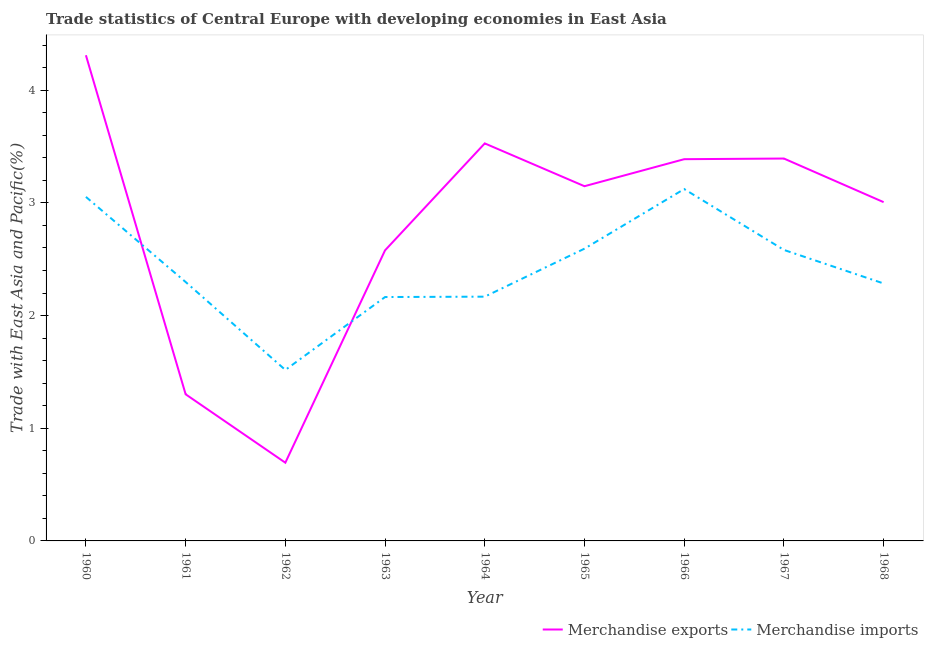How many different coloured lines are there?
Give a very brief answer. 2. Does the line corresponding to merchandise exports intersect with the line corresponding to merchandise imports?
Offer a very short reply. Yes. Is the number of lines equal to the number of legend labels?
Provide a short and direct response. Yes. What is the merchandise imports in 1966?
Offer a very short reply. 3.12. Across all years, what is the maximum merchandise imports?
Your response must be concise. 3.12. Across all years, what is the minimum merchandise exports?
Keep it short and to the point. 0.69. In which year was the merchandise imports minimum?
Offer a very short reply. 1962. What is the total merchandise imports in the graph?
Your response must be concise. 21.79. What is the difference between the merchandise imports in 1962 and that in 1963?
Your response must be concise. -0.65. What is the difference between the merchandise imports in 1964 and the merchandise exports in 1960?
Give a very brief answer. -2.14. What is the average merchandise exports per year?
Ensure brevity in your answer.  2.82. In the year 1962, what is the difference between the merchandise exports and merchandise imports?
Ensure brevity in your answer.  -0.82. In how many years, is the merchandise exports greater than 1.6 %?
Make the answer very short. 7. What is the ratio of the merchandise exports in 1962 to that in 1968?
Your answer should be compact. 0.23. What is the difference between the highest and the second highest merchandise exports?
Keep it short and to the point. 0.78. What is the difference between the highest and the lowest merchandise exports?
Your response must be concise. 3.62. In how many years, is the merchandise imports greater than the average merchandise imports taken over all years?
Provide a succinct answer. 4. Is the sum of the merchandise exports in 1964 and 1968 greater than the maximum merchandise imports across all years?
Make the answer very short. Yes. Is the merchandise imports strictly less than the merchandise exports over the years?
Offer a terse response. No. How many lines are there?
Offer a terse response. 2. Where does the legend appear in the graph?
Provide a short and direct response. Bottom right. How are the legend labels stacked?
Your response must be concise. Horizontal. What is the title of the graph?
Ensure brevity in your answer.  Trade statistics of Central Europe with developing economies in East Asia. What is the label or title of the X-axis?
Provide a short and direct response. Year. What is the label or title of the Y-axis?
Keep it short and to the point. Trade with East Asia and Pacific(%). What is the Trade with East Asia and Pacific(%) of Merchandise exports in 1960?
Offer a terse response. 4.31. What is the Trade with East Asia and Pacific(%) of Merchandise imports in 1960?
Offer a very short reply. 3.05. What is the Trade with East Asia and Pacific(%) of Merchandise exports in 1961?
Your answer should be very brief. 1.3. What is the Trade with East Asia and Pacific(%) of Merchandise imports in 1961?
Provide a short and direct response. 2.3. What is the Trade with East Asia and Pacific(%) in Merchandise exports in 1962?
Your answer should be very brief. 0.69. What is the Trade with East Asia and Pacific(%) of Merchandise imports in 1962?
Give a very brief answer. 1.52. What is the Trade with East Asia and Pacific(%) in Merchandise exports in 1963?
Offer a terse response. 2.58. What is the Trade with East Asia and Pacific(%) in Merchandise imports in 1963?
Provide a succinct answer. 2.16. What is the Trade with East Asia and Pacific(%) in Merchandise exports in 1964?
Provide a succinct answer. 3.53. What is the Trade with East Asia and Pacific(%) in Merchandise imports in 1964?
Your response must be concise. 2.17. What is the Trade with East Asia and Pacific(%) of Merchandise exports in 1965?
Your response must be concise. 3.15. What is the Trade with East Asia and Pacific(%) of Merchandise imports in 1965?
Give a very brief answer. 2.59. What is the Trade with East Asia and Pacific(%) in Merchandise exports in 1966?
Provide a succinct answer. 3.39. What is the Trade with East Asia and Pacific(%) in Merchandise imports in 1966?
Offer a very short reply. 3.12. What is the Trade with East Asia and Pacific(%) in Merchandise exports in 1967?
Give a very brief answer. 3.39. What is the Trade with East Asia and Pacific(%) in Merchandise imports in 1967?
Ensure brevity in your answer.  2.58. What is the Trade with East Asia and Pacific(%) of Merchandise exports in 1968?
Provide a short and direct response. 3.01. What is the Trade with East Asia and Pacific(%) in Merchandise imports in 1968?
Offer a very short reply. 2.28. Across all years, what is the maximum Trade with East Asia and Pacific(%) of Merchandise exports?
Make the answer very short. 4.31. Across all years, what is the maximum Trade with East Asia and Pacific(%) of Merchandise imports?
Provide a succinct answer. 3.12. Across all years, what is the minimum Trade with East Asia and Pacific(%) of Merchandise exports?
Your answer should be very brief. 0.69. Across all years, what is the minimum Trade with East Asia and Pacific(%) in Merchandise imports?
Ensure brevity in your answer.  1.52. What is the total Trade with East Asia and Pacific(%) in Merchandise exports in the graph?
Your answer should be compact. 25.35. What is the total Trade with East Asia and Pacific(%) of Merchandise imports in the graph?
Your response must be concise. 21.79. What is the difference between the Trade with East Asia and Pacific(%) in Merchandise exports in 1960 and that in 1961?
Provide a short and direct response. 3.01. What is the difference between the Trade with East Asia and Pacific(%) in Merchandise imports in 1960 and that in 1961?
Make the answer very short. 0.76. What is the difference between the Trade with East Asia and Pacific(%) of Merchandise exports in 1960 and that in 1962?
Ensure brevity in your answer.  3.62. What is the difference between the Trade with East Asia and Pacific(%) in Merchandise imports in 1960 and that in 1962?
Offer a terse response. 1.54. What is the difference between the Trade with East Asia and Pacific(%) of Merchandise exports in 1960 and that in 1963?
Give a very brief answer. 1.73. What is the difference between the Trade with East Asia and Pacific(%) in Merchandise imports in 1960 and that in 1963?
Keep it short and to the point. 0.89. What is the difference between the Trade with East Asia and Pacific(%) in Merchandise exports in 1960 and that in 1964?
Keep it short and to the point. 0.78. What is the difference between the Trade with East Asia and Pacific(%) in Merchandise imports in 1960 and that in 1964?
Provide a short and direct response. 0.89. What is the difference between the Trade with East Asia and Pacific(%) in Merchandise exports in 1960 and that in 1965?
Offer a terse response. 1.16. What is the difference between the Trade with East Asia and Pacific(%) in Merchandise imports in 1960 and that in 1965?
Your answer should be compact. 0.46. What is the difference between the Trade with East Asia and Pacific(%) of Merchandise exports in 1960 and that in 1966?
Provide a succinct answer. 0.92. What is the difference between the Trade with East Asia and Pacific(%) of Merchandise imports in 1960 and that in 1966?
Your answer should be very brief. -0.07. What is the difference between the Trade with East Asia and Pacific(%) in Merchandise imports in 1960 and that in 1967?
Offer a very short reply. 0.47. What is the difference between the Trade with East Asia and Pacific(%) of Merchandise exports in 1960 and that in 1968?
Give a very brief answer. 1.3. What is the difference between the Trade with East Asia and Pacific(%) of Merchandise imports in 1960 and that in 1968?
Make the answer very short. 0.77. What is the difference between the Trade with East Asia and Pacific(%) of Merchandise exports in 1961 and that in 1962?
Offer a very short reply. 0.61. What is the difference between the Trade with East Asia and Pacific(%) in Merchandise imports in 1961 and that in 1962?
Your response must be concise. 0.78. What is the difference between the Trade with East Asia and Pacific(%) in Merchandise exports in 1961 and that in 1963?
Provide a short and direct response. -1.28. What is the difference between the Trade with East Asia and Pacific(%) in Merchandise imports in 1961 and that in 1963?
Offer a very short reply. 0.13. What is the difference between the Trade with East Asia and Pacific(%) in Merchandise exports in 1961 and that in 1964?
Your answer should be very brief. -2.23. What is the difference between the Trade with East Asia and Pacific(%) of Merchandise imports in 1961 and that in 1964?
Provide a succinct answer. 0.13. What is the difference between the Trade with East Asia and Pacific(%) of Merchandise exports in 1961 and that in 1965?
Keep it short and to the point. -1.85. What is the difference between the Trade with East Asia and Pacific(%) of Merchandise imports in 1961 and that in 1965?
Make the answer very short. -0.3. What is the difference between the Trade with East Asia and Pacific(%) of Merchandise exports in 1961 and that in 1966?
Your answer should be compact. -2.09. What is the difference between the Trade with East Asia and Pacific(%) in Merchandise imports in 1961 and that in 1966?
Make the answer very short. -0.82. What is the difference between the Trade with East Asia and Pacific(%) in Merchandise exports in 1961 and that in 1967?
Provide a short and direct response. -2.09. What is the difference between the Trade with East Asia and Pacific(%) in Merchandise imports in 1961 and that in 1967?
Make the answer very short. -0.28. What is the difference between the Trade with East Asia and Pacific(%) of Merchandise exports in 1961 and that in 1968?
Give a very brief answer. -1.71. What is the difference between the Trade with East Asia and Pacific(%) in Merchandise imports in 1961 and that in 1968?
Make the answer very short. 0.01. What is the difference between the Trade with East Asia and Pacific(%) in Merchandise exports in 1962 and that in 1963?
Your answer should be compact. -1.88. What is the difference between the Trade with East Asia and Pacific(%) in Merchandise imports in 1962 and that in 1963?
Keep it short and to the point. -0.65. What is the difference between the Trade with East Asia and Pacific(%) of Merchandise exports in 1962 and that in 1964?
Give a very brief answer. -2.83. What is the difference between the Trade with East Asia and Pacific(%) in Merchandise imports in 1962 and that in 1964?
Your answer should be very brief. -0.65. What is the difference between the Trade with East Asia and Pacific(%) of Merchandise exports in 1962 and that in 1965?
Your answer should be compact. -2.45. What is the difference between the Trade with East Asia and Pacific(%) in Merchandise imports in 1962 and that in 1965?
Your answer should be very brief. -1.08. What is the difference between the Trade with East Asia and Pacific(%) of Merchandise exports in 1962 and that in 1966?
Your answer should be compact. -2.69. What is the difference between the Trade with East Asia and Pacific(%) in Merchandise imports in 1962 and that in 1966?
Keep it short and to the point. -1.61. What is the difference between the Trade with East Asia and Pacific(%) in Merchandise exports in 1962 and that in 1967?
Offer a very short reply. -2.7. What is the difference between the Trade with East Asia and Pacific(%) in Merchandise imports in 1962 and that in 1967?
Provide a succinct answer. -1.07. What is the difference between the Trade with East Asia and Pacific(%) of Merchandise exports in 1962 and that in 1968?
Your response must be concise. -2.31. What is the difference between the Trade with East Asia and Pacific(%) in Merchandise imports in 1962 and that in 1968?
Your answer should be compact. -0.77. What is the difference between the Trade with East Asia and Pacific(%) in Merchandise exports in 1963 and that in 1964?
Your answer should be compact. -0.95. What is the difference between the Trade with East Asia and Pacific(%) in Merchandise imports in 1963 and that in 1964?
Offer a terse response. -0. What is the difference between the Trade with East Asia and Pacific(%) of Merchandise exports in 1963 and that in 1965?
Keep it short and to the point. -0.57. What is the difference between the Trade with East Asia and Pacific(%) of Merchandise imports in 1963 and that in 1965?
Your answer should be compact. -0.43. What is the difference between the Trade with East Asia and Pacific(%) of Merchandise exports in 1963 and that in 1966?
Ensure brevity in your answer.  -0.81. What is the difference between the Trade with East Asia and Pacific(%) in Merchandise imports in 1963 and that in 1966?
Your answer should be very brief. -0.96. What is the difference between the Trade with East Asia and Pacific(%) in Merchandise exports in 1963 and that in 1967?
Your response must be concise. -0.81. What is the difference between the Trade with East Asia and Pacific(%) in Merchandise imports in 1963 and that in 1967?
Give a very brief answer. -0.42. What is the difference between the Trade with East Asia and Pacific(%) in Merchandise exports in 1963 and that in 1968?
Ensure brevity in your answer.  -0.43. What is the difference between the Trade with East Asia and Pacific(%) in Merchandise imports in 1963 and that in 1968?
Your response must be concise. -0.12. What is the difference between the Trade with East Asia and Pacific(%) in Merchandise exports in 1964 and that in 1965?
Keep it short and to the point. 0.38. What is the difference between the Trade with East Asia and Pacific(%) of Merchandise imports in 1964 and that in 1965?
Your response must be concise. -0.43. What is the difference between the Trade with East Asia and Pacific(%) of Merchandise exports in 1964 and that in 1966?
Your answer should be very brief. 0.14. What is the difference between the Trade with East Asia and Pacific(%) of Merchandise imports in 1964 and that in 1966?
Your answer should be very brief. -0.96. What is the difference between the Trade with East Asia and Pacific(%) of Merchandise exports in 1964 and that in 1967?
Provide a succinct answer. 0.13. What is the difference between the Trade with East Asia and Pacific(%) of Merchandise imports in 1964 and that in 1967?
Provide a succinct answer. -0.41. What is the difference between the Trade with East Asia and Pacific(%) of Merchandise exports in 1964 and that in 1968?
Provide a short and direct response. 0.52. What is the difference between the Trade with East Asia and Pacific(%) in Merchandise imports in 1964 and that in 1968?
Your response must be concise. -0.12. What is the difference between the Trade with East Asia and Pacific(%) in Merchandise exports in 1965 and that in 1966?
Offer a very short reply. -0.24. What is the difference between the Trade with East Asia and Pacific(%) in Merchandise imports in 1965 and that in 1966?
Offer a very short reply. -0.53. What is the difference between the Trade with East Asia and Pacific(%) of Merchandise exports in 1965 and that in 1967?
Your answer should be compact. -0.25. What is the difference between the Trade with East Asia and Pacific(%) of Merchandise imports in 1965 and that in 1967?
Offer a terse response. 0.01. What is the difference between the Trade with East Asia and Pacific(%) in Merchandise exports in 1965 and that in 1968?
Offer a terse response. 0.14. What is the difference between the Trade with East Asia and Pacific(%) in Merchandise imports in 1965 and that in 1968?
Give a very brief answer. 0.31. What is the difference between the Trade with East Asia and Pacific(%) in Merchandise exports in 1966 and that in 1967?
Your response must be concise. -0.01. What is the difference between the Trade with East Asia and Pacific(%) in Merchandise imports in 1966 and that in 1967?
Keep it short and to the point. 0.54. What is the difference between the Trade with East Asia and Pacific(%) in Merchandise exports in 1966 and that in 1968?
Keep it short and to the point. 0.38. What is the difference between the Trade with East Asia and Pacific(%) in Merchandise imports in 1966 and that in 1968?
Give a very brief answer. 0.84. What is the difference between the Trade with East Asia and Pacific(%) in Merchandise exports in 1967 and that in 1968?
Provide a succinct answer. 0.39. What is the difference between the Trade with East Asia and Pacific(%) in Merchandise imports in 1967 and that in 1968?
Offer a very short reply. 0.3. What is the difference between the Trade with East Asia and Pacific(%) in Merchandise exports in 1960 and the Trade with East Asia and Pacific(%) in Merchandise imports in 1961?
Your answer should be very brief. 2.01. What is the difference between the Trade with East Asia and Pacific(%) of Merchandise exports in 1960 and the Trade with East Asia and Pacific(%) of Merchandise imports in 1962?
Provide a succinct answer. 2.79. What is the difference between the Trade with East Asia and Pacific(%) in Merchandise exports in 1960 and the Trade with East Asia and Pacific(%) in Merchandise imports in 1963?
Offer a terse response. 2.15. What is the difference between the Trade with East Asia and Pacific(%) in Merchandise exports in 1960 and the Trade with East Asia and Pacific(%) in Merchandise imports in 1964?
Offer a terse response. 2.14. What is the difference between the Trade with East Asia and Pacific(%) of Merchandise exports in 1960 and the Trade with East Asia and Pacific(%) of Merchandise imports in 1965?
Offer a very short reply. 1.72. What is the difference between the Trade with East Asia and Pacific(%) of Merchandise exports in 1960 and the Trade with East Asia and Pacific(%) of Merchandise imports in 1966?
Offer a terse response. 1.19. What is the difference between the Trade with East Asia and Pacific(%) of Merchandise exports in 1960 and the Trade with East Asia and Pacific(%) of Merchandise imports in 1967?
Your answer should be compact. 1.73. What is the difference between the Trade with East Asia and Pacific(%) of Merchandise exports in 1960 and the Trade with East Asia and Pacific(%) of Merchandise imports in 1968?
Ensure brevity in your answer.  2.03. What is the difference between the Trade with East Asia and Pacific(%) in Merchandise exports in 1961 and the Trade with East Asia and Pacific(%) in Merchandise imports in 1962?
Ensure brevity in your answer.  -0.22. What is the difference between the Trade with East Asia and Pacific(%) of Merchandise exports in 1961 and the Trade with East Asia and Pacific(%) of Merchandise imports in 1963?
Your answer should be very brief. -0.86. What is the difference between the Trade with East Asia and Pacific(%) of Merchandise exports in 1961 and the Trade with East Asia and Pacific(%) of Merchandise imports in 1964?
Make the answer very short. -0.87. What is the difference between the Trade with East Asia and Pacific(%) in Merchandise exports in 1961 and the Trade with East Asia and Pacific(%) in Merchandise imports in 1965?
Make the answer very short. -1.29. What is the difference between the Trade with East Asia and Pacific(%) of Merchandise exports in 1961 and the Trade with East Asia and Pacific(%) of Merchandise imports in 1966?
Offer a terse response. -1.82. What is the difference between the Trade with East Asia and Pacific(%) in Merchandise exports in 1961 and the Trade with East Asia and Pacific(%) in Merchandise imports in 1967?
Make the answer very short. -1.28. What is the difference between the Trade with East Asia and Pacific(%) of Merchandise exports in 1961 and the Trade with East Asia and Pacific(%) of Merchandise imports in 1968?
Offer a very short reply. -0.98. What is the difference between the Trade with East Asia and Pacific(%) in Merchandise exports in 1962 and the Trade with East Asia and Pacific(%) in Merchandise imports in 1963?
Ensure brevity in your answer.  -1.47. What is the difference between the Trade with East Asia and Pacific(%) in Merchandise exports in 1962 and the Trade with East Asia and Pacific(%) in Merchandise imports in 1964?
Provide a short and direct response. -1.47. What is the difference between the Trade with East Asia and Pacific(%) in Merchandise exports in 1962 and the Trade with East Asia and Pacific(%) in Merchandise imports in 1965?
Provide a short and direct response. -1.9. What is the difference between the Trade with East Asia and Pacific(%) in Merchandise exports in 1962 and the Trade with East Asia and Pacific(%) in Merchandise imports in 1966?
Provide a succinct answer. -2.43. What is the difference between the Trade with East Asia and Pacific(%) in Merchandise exports in 1962 and the Trade with East Asia and Pacific(%) in Merchandise imports in 1967?
Provide a short and direct response. -1.89. What is the difference between the Trade with East Asia and Pacific(%) of Merchandise exports in 1962 and the Trade with East Asia and Pacific(%) of Merchandise imports in 1968?
Ensure brevity in your answer.  -1.59. What is the difference between the Trade with East Asia and Pacific(%) of Merchandise exports in 1963 and the Trade with East Asia and Pacific(%) of Merchandise imports in 1964?
Provide a succinct answer. 0.41. What is the difference between the Trade with East Asia and Pacific(%) in Merchandise exports in 1963 and the Trade with East Asia and Pacific(%) in Merchandise imports in 1965?
Your answer should be compact. -0.01. What is the difference between the Trade with East Asia and Pacific(%) in Merchandise exports in 1963 and the Trade with East Asia and Pacific(%) in Merchandise imports in 1966?
Your response must be concise. -0.54. What is the difference between the Trade with East Asia and Pacific(%) in Merchandise exports in 1963 and the Trade with East Asia and Pacific(%) in Merchandise imports in 1967?
Your answer should be compact. -0. What is the difference between the Trade with East Asia and Pacific(%) in Merchandise exports in 1963 and the Trade with East Asia and Pacific(%) in Merchandise imports in 1968?
Offer a very short reply. 0.29. What is the difference between the Trade with East Asia and Pacific(%) of Merchandise exports in 1964 and the Trade with East Asia and Pacific(%) of Merchandise imports in 1965?
Provide a short and direct response. 0.93. What is the difference between the Trade with East Asia and Pacific(%) in Merchandise exports in 1964 and the Trade with East Asia and Pacific(%) in Merchandise imports in 1966?
Offer a very short reply. 0.41. What is the difference between the Trade with East Asia and Pacific(%) in Merchandise exports in 1964 and the Trade with East Asia and Pacific(%) in Merchandise imports in 1967?
Your response must be concise. 0.95. What is the difference between the Trade with East Asia and Pacific(%) of Merchandise exports in 1964 and the Trade with East Asia and Pacific(%) of Merchandise imports in 1968?
Offer a terse response. 1.24. What is the difference between the Trade with East Asia and Pacific(%) of Merchandise exports in 1965 and the Trade with East Asia and Pacific(%) of Merchandise imports in 1966?
Provide a short and direct response. 0.03. What is the difference between the Trade with East Asia and Pacific(%) in Merchandise exports in 1965 and the Trade with East Asia and Pacific(%) in Merchandise imports in 1967?
Give a very brief answer. 0.57. What is the difference between the Trade with East Asia and Pacific(%) of Merchandise exports in 1965 and the Trade with East Asia and Pacific(%) of Merchandise imports in 1968?
Make the answer very short. 0.86. What is the difference between the Trade with East Asia and Pacific(%) in Merchandise exports in 1966 and the Trade with East Asia and Pacific(%) in Merchandise imports in 1967?
Make the answer very short. 0.81. What is the difference between the Trade with East Asia and Pacific(%) in Merchandise exports in 1966 and the Trade with East Asia and Pacific(%) in Merchandise imports in 1968?
Your answer should be compact. 1.1. What is the difference between the Trade with East Asia and Pacific(%) of Merchandise exports in 1967 and the Trade with East Asia and Pacific(%) of Merchandise imports in 1968?
Provide a succinct answer. 1.11. What is the average Trade with East Asia and Pacific(%) in Merchandise exports per year?
Your answer should be compact. 2.82. What is the average Trade with East Asia and Pacific(%) of Merchandise imports per year?
Keep it short and to the point. 2.42. In the year 1960, what is the difference between the Trade with East Asia and Pacific(%) in Merchandise exports and Trade with East Asia and Pacific(%) in Merchandise imports?
Make the answer very short. 1.26. In the year 1961, what is the difference between the Trade with East Asia and Pacific(%) in Merchandise exports and Trade with East Asia and Pacific(%) in Merchandise imports?
Provide a succinct answer. -1. In the year 1962, what is the difference between the Trade with East Asia and Pacific(%) of Merchandise exports and Trade with East Asia and Pacific(%) of Merchandise imports?
Provide a short and direct response. -0.82. In the year 1963, what is the difference between the Trade with East Asia and Pacific(%) in Merchandise exports and Trade with East Asia and Pacific(%) in Merchandise imports?
Keep it short and to the point. 0.41. In the year 1964, what is the difference between the Trade with East Asia and Pacific(%) in Merchandise exports and Trade with East Asia and Pacific(%) in Merchandise imports?
Provide a short and direct response. 1.36. In the year 1965, what is the difference between the Trade with East Asia and Pacific(%) of Merchandise exports and Trade with East Asia and Pacific(%) of Merchandise imports?
Offer a terse response. 0.55. In the year 1966, what is the difference between the Trade with East Asia and Pacific(%) in Merchandise exports and Trade with East Asia and Pacific(%) in Merchandise imports?
Your response must be concise. 0.27. In the year 1967, what is the difference between the Trade with East Asia and Pacific(%) of Merchandise exports and Trade with East Asia and Pacific(%) of Merchandise imports?
Your response must be concise. 0.81. In the year 1968, what is the difference between the Trade with East Asia and Pacific(%) in Merchandise exports and Trade with East Asia and Pacific(%) in Merchandise imports?
Provide a succinct answer. 0.72. What is the ratio of the Trade with East Asia and Pacific(%) of Merchandise exports in 1960 to that in 1961?
Make the answer very short. 3.31. What is the ratio of the Trade with East Asia and Pacific(%) of Merchandise imports in 1960 to that in 1961?
Give a very brief answer. 1.33. What is the ratio of the Trade with East Asia and Pacific(%) of Merchandise exports in 1960 to that in 1962?
Your answer should be compact. 6.21. What is the ratio of the Trade with East Asia and Pacific(%) in Merchandise imports in 1960 to that in 1962?
Ensure brevity in your answer.  2.01. What is the ratio of the Trade with East Asia and Pacific(%) in Merchandise exports in 1960 to that in 1963?
Your answer should be very brief. 1.67. What is the ratio of the Trade with East Asia and Pacific(%) in Merchandise imports in 1960 to that in 1963?
Make the answer very short. 1.41. What is the ratio of the Trade with East Asia and Pacific(%) of Merchandise exports in 1960 to that in 1964?
Provide a short and direct response. 1.22. What is the ratio of the Trade with East Asia and Pacific(%) in Merchandise imports in 1960 to that in 1964?
Make the answer very short. 1.41. What is the ratio of the Trade with East Asia and Pacific(%) of Merchandise exports in 1960 to that in 1965?
Provide a succinct answer. 1.37. What is the ratio of the Trade with East Asia and Pacific(%) in Merchandise imports in 1960 to that in 1965?
Offer a terse response. 1.18. What is the ratio of the Trade with East Asia and Pacific(%) in Merchandise exports in 1960 to that in 1966?
Your answer should be compact. 1.27. What is the ratio of the Trade with East Asia and Pacific(%) in Merchandise imports in 1960 to that in 1966?
Offer a very short reply. 0.98. What is the ratio of the Trade with East Asia and Pacific(%) in Merchandise exports in 1960 to that in 1967?
Keep it short and to the point. 1.27. What is the ratio of the Trade with East Asia and Pacific(%) in Merchandise imports in 1960 to that in 1967?
Make the answer very short. 1.18. What is the ratio of the Trade with East Asia and Pacific(%) of Merchandise exports in 1960 to that in 1968?
Your answer should be compact. 1.43. What is the ratio of the Trade with East Asia and Pacific(%) in Merchandise imports in 1960 to that in 1968?
Give a very brief answer. 1.34. What is the ratio of the Trade with East Asia and Pacific(%) of Merchandise exports in 1961 to that in 1962?
Provide a succinct answer. 1.87. What is the ratio of the Trade with East Asia and Pacific(%) in Merchandise imports in 1961 to that in 1962?
Your answer should be very brief. 1.51. What is the ratio of the Trade with East Asia and Pacific(%) of Merchandise exports in 1961 to that in 1963?
Keep it short and to the point. 0.5. What is the ratio of the Trade with East Asia and Pacific(%) of Merchandise imports in 1961 to that in 1963?
Give a very brief answer. 1.06. What is the ratio of the Trade with East Asia and Pacific(%) in Merchandise exports in 1961 to that in 1964?
Keep it short and to the point. 0.37. What is the ratio of the Trade with East Asia and Pacific(%) of Merchandise imports in 1961 to that in 1964?
Make the answer very short. 1.06. What is the ratio of the Trade with East Asia and Pacific(%) in Merchandise exports in 1961 to that in 1965?
Ensure brevity in your answer.  0.41. What is the ratio of the Trade with East Asia and Pacific(%) of Merchandise imports in 1961 to that in 1965?
Provide a short and direct response. 0.89. What is the ratio of the Trade with East Asia and Pacific(%) in Merchandise exports in 1961 to that in 1966?
Provide a short and direct response. 0.38. What is the ratio of the Trade with East Asia and Pacific(%) of Merchandise imports in 1961 to that in 1966?
Provide a succinct answer. 0.74. What is the ratio of the Trade with East Asia and Pacific(%) of Merchandise exports in 1961 to that in 1967?
Provide a succinct answer. 0.38. What is the ratio of the Trade with East Asia and Pacific(%) in Merchandise imports in 1961 to that in 1967?
Provide a short and direct response. 0.89. What is the ratio of the Trade with East Asia and Pacific(%) of Merchandise exports in 1961 to that in 1968?
Provide a succinct answer. 0.43. What is the ratio of the Trade with East Asia and Pacific(%) of Merchandise exports in 1962 to that in 1963?
Your response must be concise. 0.27. What is the ratio of the Trade with East Asia and Pacific(%) of Merchandise imports in 1962 to that in 1963?
Make the answer very short. 0.7. What is the ratio of the Trade with East Asia and Pacific(%) of Merchandise exports in 1962 to that in 1964?
Your answer should be very brief. 0.2. What is the ratio of the Trade with East Asia and Pacific(%) in Merchandise imports in 1962 to that in 1964?
Make the answer very short. 0.7. What is the ratio of the Trade with East Asia and Pacific(%) of Merchandise exports in 1962 to that in 1965?
Your answer should be very brief. 0.22. What is the ratio of the Trade with East Asia and Pacific(%) of Merchandise imports in 1962 to that in 1965?
Your response must be concise. 0.58. What is the ratio of the Trade with East Asia and Pacific(%) in Merchandise exports in 1962 to that in 1966?
Ensure brevity in your answer.  0.2. What is the ratio of the Trade with East Asia and Pacific(%) of Merchandise imports in 1962 to that in 1966?
Make the answer very short. 0.49. What is the ratio of the Trade with East Asia and Pacific(%) in Merchandise exports in 1962 to that in 1967?
Make the answer very short. 0.2. What is the ratio of the Trade with East Asia and Pacific(%) in Merchandise imports in 1962 to that in 1967?
Make the answer very short. 0.59. What is the ratio of the Trade with East Asia and Pacific(%) of Merchandise exports in 1962 to that in 1968?
Ensure brevity in your answer.  0.23. What is the ratio of the Trade with East Asia and Pacific(%) of Merchandise imports in 1962 to that in 1968?
Offer a very short reply. 0.66. What is the ratio of the Trade with East Asia and Pacific(%) of Merchandise exports in 1963 to that in 1964?
Give a very brief answer. 0.73. What is the ratio of the Trade with East Asia and Pacific(%) in Merchandise exports in 1963 to that in 1965?
Your answer should be very brief. 0.82. What is the ratio of the Trade with East Asia and Pacific(%) in Merchandise imports in 1963 to that in 1965?
Give a very brief answer. 0.83. What is the ratio of the Trade with East Asia and Pacific(%) in Merchandise exports in 1963 to that in 1966?
Ensure brevity in your answer.  0.76. What is the ratio of the Trade with East Asia and Pacific(%) of Merchandise imports in 1963 to that in 1966?
Offer a terse response. 0.69. What is the ratio of the Trade with East Asia and Pacific(%) of Merchandise exports in 1963 to that in 1967?
Provide a short and direct response. 0.76. What is the ratio of the Trade with East Asia and Pacific(%) of Merchandise imports in 1963 to that in 1967?
Keep it short and to the point. 0.84. What is the ratio of the Trade with East Asia and Pacific(%) of Merchandise exports in 1963 to that in 1968?
Your answer should be very brief. 0.86. What is the ratio of the Trade with East Asia and Pacific(%) of Merchandise imports in 1963 to that in 1968?
Make the answer very short. 0.95. What is the ratio of the Trade with East Asia and Pacific(%) in Merchandise exports in 1964 to that in 1965?
Your answer should be compact. 1.12. What is the ratio of the Trade with East Asia and Pacific(%) of Merchandise imports in 1964 to that in 1965?
Keep it short and to the point. 0.84. What is the ratio of the Trade with East Asia and Pacific(%) of Merchandise exports in 1964 to that in 1966?
Offer a very short reply. 1.04. What is the ratio of the Trade with East Asia and Pacific(%) in Merchandise imports in 1964 to that in 1966?
Provide a succinct answer. 0.69. What is the ratio of the Trade with East Asia and Pacific(%) of Merchandise exports in 1964 to that in 1967?
Make the answer very short. 1.04. What is the ratio of the Trade with East Asia and Pacific(%) in Merchandise imports in 1964 to that in 1967?
Offer a terse response. 0.84. What is the ratio of the Trade with East Asia and Pacific(%) of Merchandise exports in 1964 to that in 1968?
Offer a terse response. 1.17. What is the ratio of the Trade with East Asia and Pacific(%) of Merchandise imports in 1964 to that in 1968?
Offer a very short reply. 0.95. What is the ratio of the Trade with East Asia and Pacific(%) in Merchandise exports in 1965 to that in 1966?
Offer a very short reply. 0.93. What is the ratio of the Trade with East Asia and Pacific(%) in Merchandise imports in 1965 to that in 1966?
Your answer should be compact. 0.83. What is the ratio of the Trade with East Asia and Pacific(%) in Merchandise exports in 1965 to that in 1967?
Provide a short and direct response. 0.93. What is the ratio of the Trade with East Asia and Pacific(%) of Merchandise imports in 1965 to that in 1967?
Give a very brief answer. 1. What is the ratio of the Trade with East Asia and Pacific(%) of Merchandise exports in 1965 to that in 1968?
Your response must be concise. 1.05. What is the ratio of the Trade with East Asia and Pacific(%) in Merchandise imports in 1965 to that in 1968?
Offer a terse response. 1.14. What is the ratio of the Trade with East Asia and Pacific(%) in Merchandise exports in 1966 to that in 1967?
Your answer should be very brief. 1. What is the ratio of the Trade with East Asia and Pacific(%) of Merchandise imports in 1966 to that in 1967?
Keep it short and to the point. 1.21. What is the ratio of the Trade with East Asia and Pacific(%) in Merchandise exports in 1966 to that in 1968?
Your response must be concise. 1.13. What is the ratio of the Trade with East Asia and Pacific(%) in Merchandise imports in 1966 to that in 1968?
Your answer should be compact. 1.37. What is the ratio of the Trade with East Asia and Pacific(%) in Merchandise exports in 1967 to that in 1968?
Your answer should be compact. 1.13. What is the ratio of the Trade with East Asia and Pacific(%) in Merchandise imports in 1967 to that in 1968?
Ensure brevity in your answer.  1.13. What is the difference between the highest and the second highest Trade with East Asia and Pacific(%) in Merchandise exports?
Ensure brevity in your answer.  0.78. What is the difference between the highest and the second highest Trade with East Asia and Pacific(%) of Merchandise imports?
Your response must be concise. 0.07. What is the difference between the highest and the lowest Trade with East Asia and Pacific(%) of Merchandise exports?
Provide a succinct answer. 3.62. What is the difference between the highest and the lowest Trade with East Asia and Pacific(%) of Merchandise imports?
Provide a succinct answer. 1.61. 